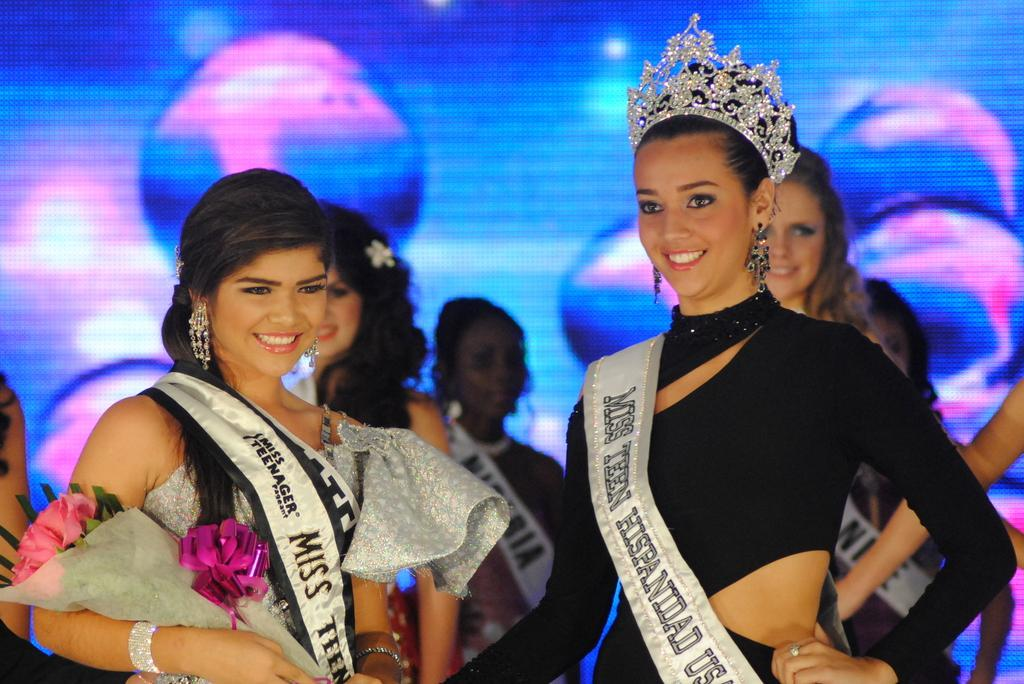Provide a one-sentence caption for the provided image. the word Miss on one of the show contestants. 